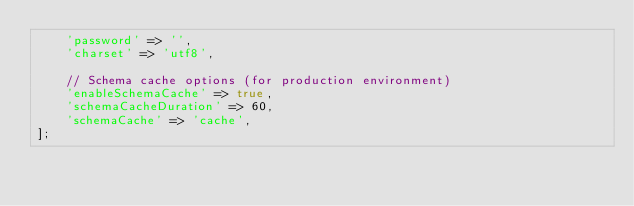Convert code to text. <code><loc_0><loc_0><loc_500><loc_500><_PHP_>    'password' => '',
    'charset' => 'utf8',

    // Schema cache options (for production environment)
    'enableSchemaCache' => true,
    'schemaCacheDuration' => 60,
    'schemaCache' => 'cache',
];
</code> 